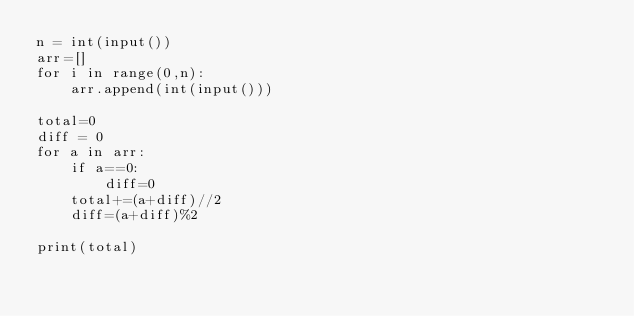<code> <loc_0><loc_0><loc_500><loc_500><_Python_>n = int(input())
arr=[]
for i in range(0,n):
    arr.append(int(input()))

total=0
diff = 0
for a in arr:
    if a==0:
        diff=0
    total+=(a+diff)//2
    diff=(a+diff)%2

print(total)
</code> 